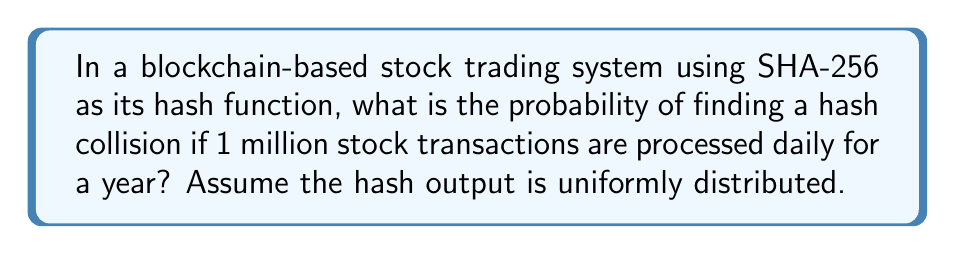Give your solution to this math problem. Let's approach this step-by-step:

1. SHA-256 produces a 256-bit hash output. This means there are $2^{256}$ possible hash values.

2. The number of transactions in a year:
   $$ n = 1,000,000 \times 365 = 365,000,000 $$

3. This scenario is an instance of the birthday problem. The probability of a collision can be approximated using the formula:

   $$ P(\text{collision}) \approx 1 - e^{-\frac{n^2}{2m}} $$

   Where $n$ is the number of transactions and $m$ is the number of possible hash values.

4. Substituting our values:
   $$ P(\text{collision}) \approx 1 - e^{-\frac{365,000,000^2}{2 \times 2^{256}}} $$

5. Simplifying:
   $$ P(\text{collision}) \approx 1 - e^{-\frac{133,225,000,000,000,000}{2^{257}}} $$

6. Using a calculator:
   $$ P(\text{collision}) \approx 1 - e^{-9.22 \times 10^{-61}} $$
   $$ P(\text{collision}) \approx 9.22 \times 10^{-61} $$

This extremely small probability demonstrates the high collision resistance of SHA-256 in this context.
Answer: $9.22 \times 10^{-61}$ 